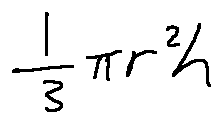<formula> <loc_0><loc_0><loc_500><loc_500>\frac { 1 } { 3 } \pi r ^ { 2 } h</formula> 